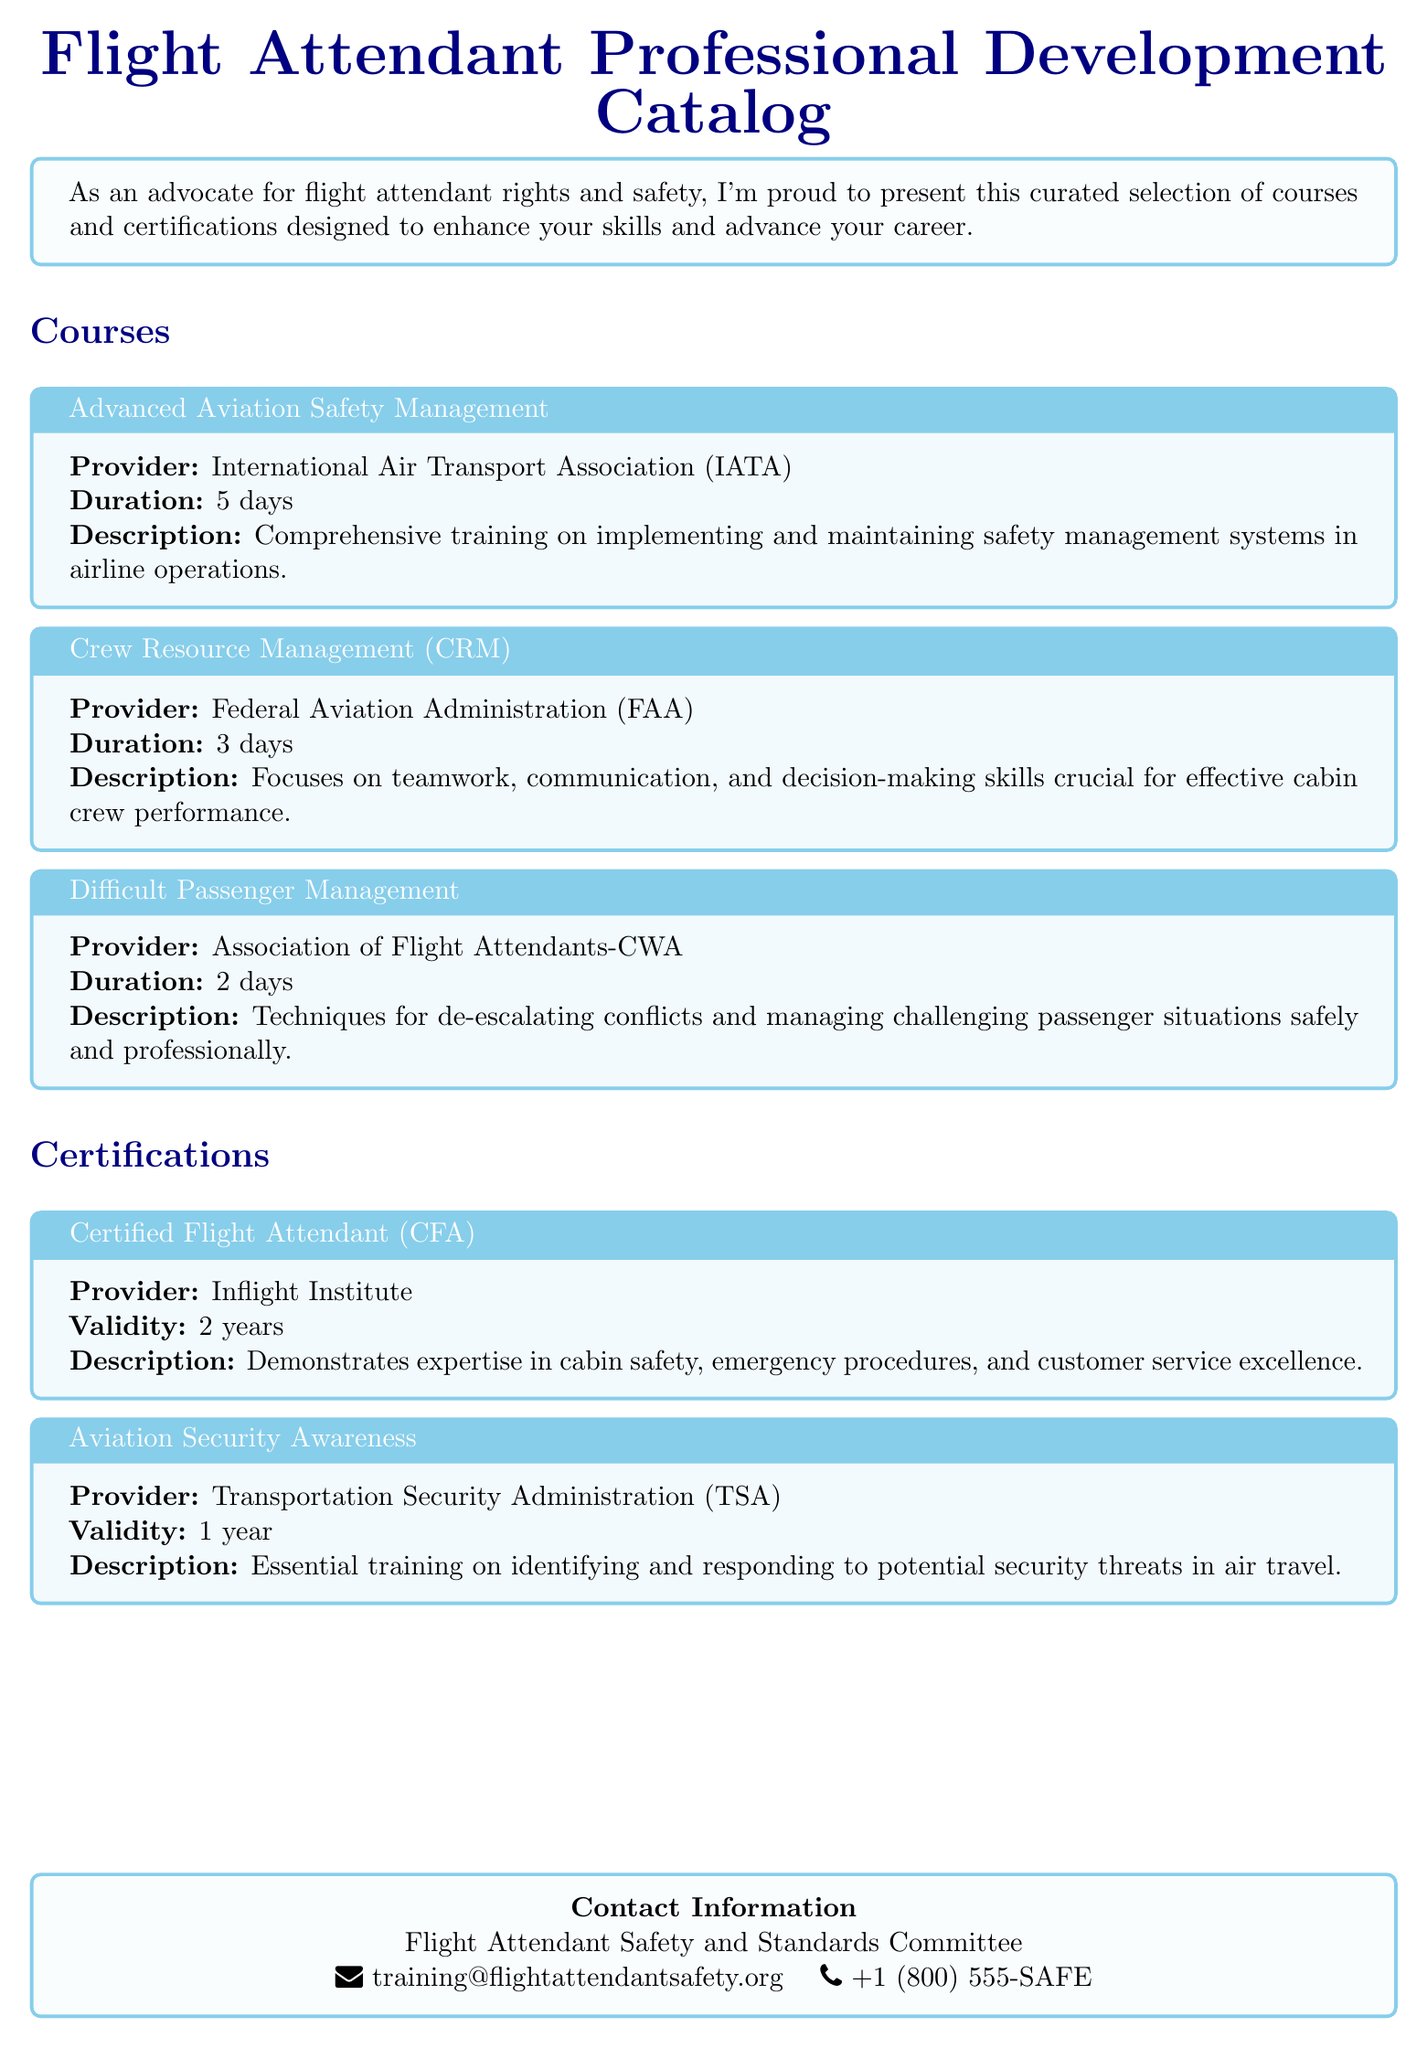What is the title of the catalog? The title of the catalog is presented prominently at the top of the document.
Answer: Flight Attendant Professional Development Catalog Who provided the Advanced Aviation Safety Management course? The course provider is listed directly under the course title.
Answer: International Air Transport Association (IATA) How long does the Difficult Passenger Management course last? The duration of the course is specified in days, making it easy to retrieve.
Answer: 2 days What certification is valid for 2 years? The validity period is clearly stated for each certification.
Answer: Certified Flight Attendant (CFA) What agency offers the Aviation Security Awareness certification? The provider of each certification is mentioned explicitly in the document.
Answer: Transportation Security Administration (TSA) Which course focuses on teamwork and communication? The focus or objective of each course is described in its description.
Answer: Crew Resource Management (CRM) How many days is the Crew Resource Management course? The duration of the course is clearly indicated in the catalog.
Answer: 3 days What type of training is emphasized in the Difficult Passenger Management course? The description provides insight into the content and focus of the course.
Answer: De-escalating conflicts What is the contact information email for flight attendant safety inquiries? The contact information section contains an email address for further communication.
Answer: training@flightattendantsafety.org 